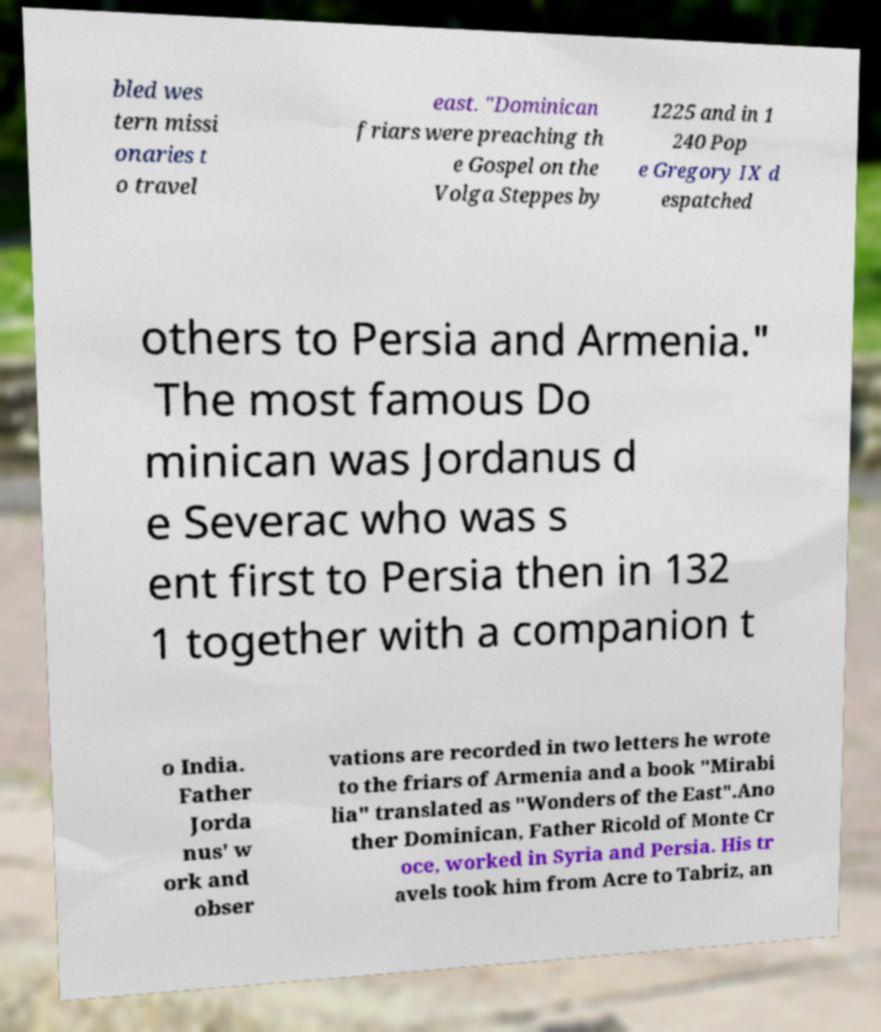Please identify and transcribe the text found in this image. bled wes tern missi onaries t o travel east. "Dominican friars were preaching th e Gospel on the Volga Steppes by 1225 and in 1 240 Pop e Gregory IX d espatched others to Persia and Armenia." The most famous Do minican was Jordanus d e Severac who was s ent first to Persia then in 132 1 together with a companion t o India. Father Jorda nus' w ork and obser vations are recorded in two letters he wrote to the friars of Armenia and a book "Mirabi lia" translated as "Wonders of the East".Ano ther Dominican, Father Ricold of Monte Cr oce, worked in Syria and Persia. His tr avels took him from Acre to Tabriz, an 